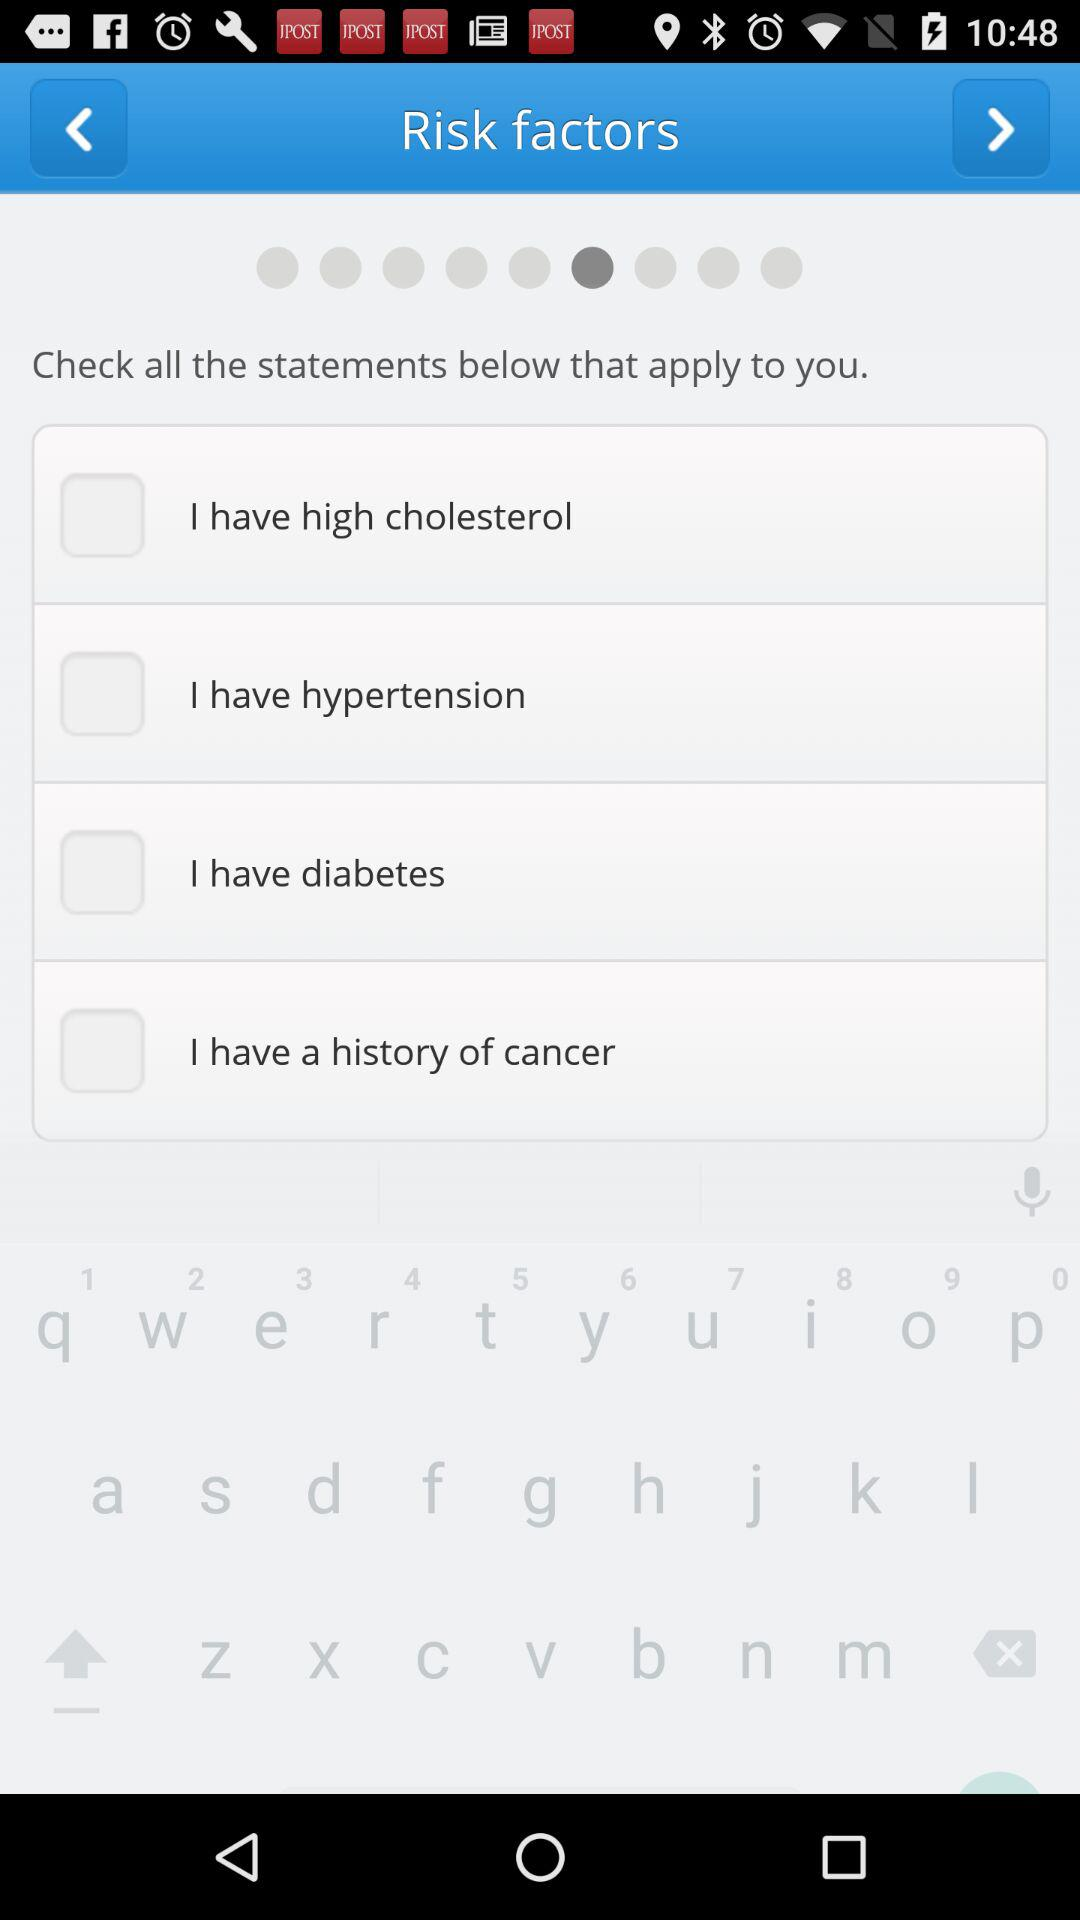How many risk factors are there to check?
Answer the question using a single word or phrase. 4 